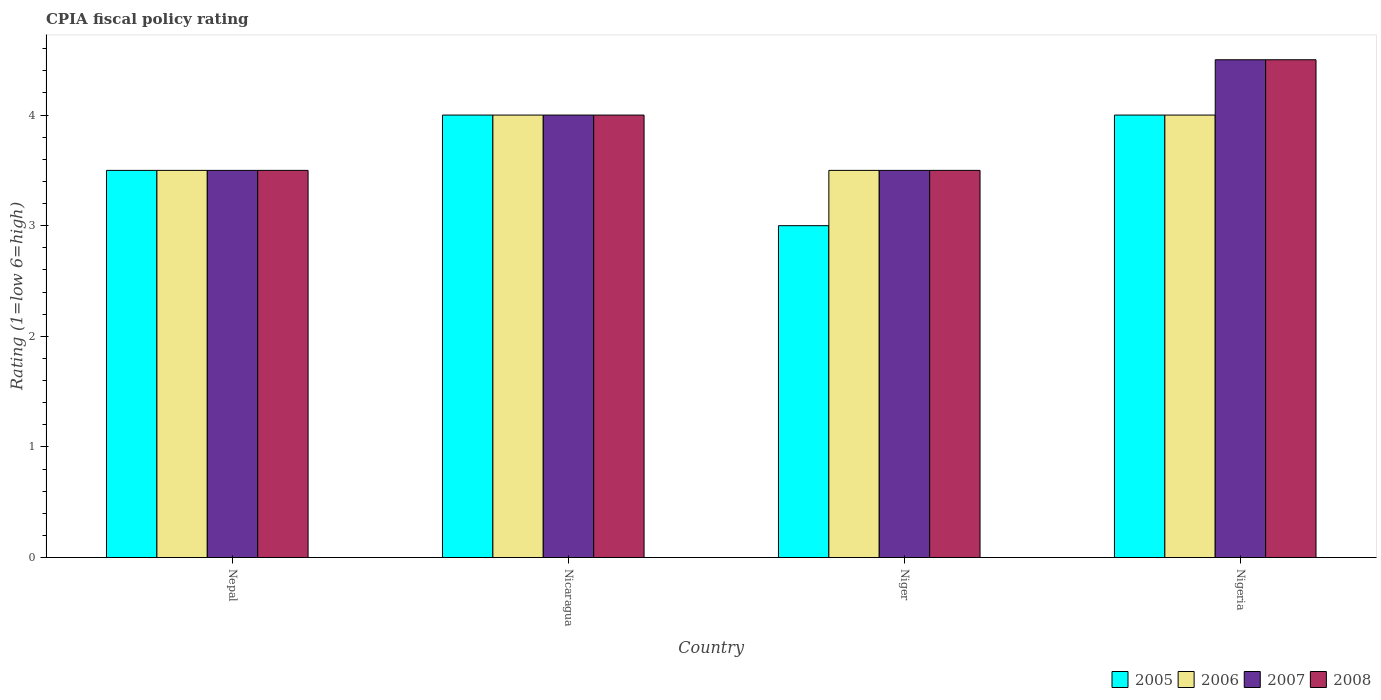How many groups of bars are there?
Provide a short and direct response. 4. How many bars are there on the 3rd tick from the left?
Ensure brevity in your answer.  4. What is the label of the 2nd group of bars from the left?
Offer a very short reply. Nicaragua. In how many cases, is the number of bars for a given country not equal to the number of legend labels?
Keep it short and to the point. 0. What is the CPIA rating in 2008 in Nigeria?
Provide a succinct answer. 4.5. Across all countries, what is the maximum CPIA rating in 2005?
Offer a very short reply. 4. Across all countries, what is the minimum CPIA rating in 2007?
Your answer should be compact. 3.5. In which country was the CPIA rating in 2008 maximum?
Your answer should be compact. Nigeria. In which country was the CPIA rating in 2007 minimum?
Provide a succinct answer. Nepal. What is the total CPIA rating in 2006 in the graph?
Provide a short and direct response. 15. What is the difference between the CPIA rating in 2006 in Nepal and that in Niger?
Give a very brief answer. 0. What is the average CPIA rating in 2005 per country?
Offer a terse response. 3.62. What is the difference between the CPIA rating of/in 2007 and CPIA rating of/in 2006 in Nepal?
Provide a succinct answer. 0. What is the ratio of the CPIA rating in 2006 in Nepal to that in Niger?
Your response must be concise. 1. What is the difference between the highest and the lowest CPIA rating in 2007?
Keep it short and to the point. 1. In how many countries, is the CPIA rating in 2008 greater than the average CPIA rating in 2008 taken over all countries?
Your answer should be compact. 2. Is the sum of the CPIA rating in 2005 in Nicaragua and Niger greater than the maximum CPIA rating in 2008 across all countries?
Your answer should be compact. Yes. Is it the case that in every country, the sum of the CPIA rating in 2007 and CPIA rating in 2005 is greater than the sum of CPIA rating in 2008 and CPIA rating in 2006?
Ensure brevity in your answer.  No. What does the 3rd bar from the left in Nicaragua represents?
Provide a short and direct response. 2007. Is it the case that in every country, the sum of the CPIA rating in 2005 and CPIA rating in 2007 is greater than the CPIA rating in 2008?
Provide a succinct answer. Yes. How many bars are there?
Make the answer very short. 16. What is the difference between two consecutive major ticks on the Y-axis?
Give a very brief answer. 1. Where does the legend appear in the graph?
Offer a terse response. Bottom right. How are the legend labels stacked?
Offer a terse response. Horizontal. What is the title of the graph?
Offer a very short reply. CPIA fiscal policy rating. What is the label or title of the X-axis?
Give a very brief answer. Country. What is the Rating (1=low 6=high) in 2007 in Nepal?
Offer a terse response. 3.5. What is the Rating (1=low 6=high) in 2007 in Nicaragua?
Ensure brevity in your answer.  4. What is the Rating (1=low 6=high) in 2008 in Nicaragua?
Ensure brevity in your answer.  4. What is the Rating (1=low 6=high) of 2007 in Niger?
Provide a short and direct response. 3.5. What is the Rating (1=low 6=high) of 2007 in Nigeria?
Give a very brief answer. 4.5. What is the Rating (1=low 6=high) in 2008 in Nigeria?
Provide a short and direct response. 4.5. Across all countries, what is the maximum Rating (1=low 6=high) of 2005?
Make the answer very short. 4. Across all countries, what is the maximum Rating (1=low 6=high) in 2006?
Your answer should be compact. 4. Across all countries, what is the maximum Rating (1=low 6=high) in 2007?
Offer a terse response. 4.5. Across all countries, what is the maximum Rating (1=low 6=high) of 2008?
Provide a short and direct response. 4.5. Across all countries, what is the minimum Rating (1=low 6=high) of 2008?
Provide a succinct answer. 3.5. What is the total Rating (1=low 6=high) in 2006 in the graph?
Your answer should be compact. 15. What is the total Rating (1=low 6=high) in 2008 in the graph?
Your response must be concise. 15.5. What is the difference between the Rating (1=low 6=high) of 2006 in Nepal and that in Niger?
Give a very brief answer. 0. What is the difference between the Rating (1=low 6=high) of 2007 in Nepal and that in Niger?
Your answer should be compact. 0. What is the difference between the Rating (1=low 6=high) of 2005 in Nepal and that in Nigeria?
Provide a succinct answer. -0.5. What is the difference between the Rating (1=low 6=high) of 2006 in Nepal and that in Nigeria?
Your answer should be compact. -0.5. What is the difference between the Rating (1=low 6=high) of 2005 in Nicaragua and that in Niger?
Your answer should be very brief. 1. What is the difference between the Rating (1=low 6=high) of 2007 in Nicaragua and that in Niger?
Make the answer very short. 0.5. What is the difference between the Rating (1=low 6=high) of 2008 in Nicaragua and that in Niger?
Ensure brevity in your answer.  0.5. What is the difference between the Rating (1=low 6=high) in 2006 in Nicaragua and that in Nigeria?
Ensure brevity in your answer.  0. What is the difference between the Rating (1=low 6=high) of 2007 in Nicaragua and that in Nigeria?
Provide a short and direct response. -0.5. What is the difference between the Rating (1=low 6=high) in 2008 in Nicaragua and that in Nigeria?
Your response must be concise. -0.5. What is the difference between the Rating (1=low 6=high) in 2005 in Niger and that in Nigeria?
Your answer should be very brief. -1. What is the difference between the Rating (1=low 6=high) of 2007 in Niger and that in Nigeria?
Ensure brevity in your answer.  -1. What is the difference between the Rating (1=low 6=high) of 2005 in Nepal and the Rating (1=low 6=high) of 2007 in Nicaragua?
Offer a terse response. -0.5. What is the difference between the Rating (1=low 6=high) of 2006 in Nepal and the Rating (1=low 6=high) of 2008 in Nicaragua?
Your answer should be very brief. -0.5. What is the difference between the Rating (1=low 6=high) in 2005 in Nepal and the Rating (1=low 6=high) in 2006 in Niger?
Give a very brief answer. 0. What is the difference between the Rating (1=low 6=high) in 2005 in Nepal and the Rating (1=low 6=high) in 2007 in Niger?
Your answer should be compact. 0. What is the difference between the Rating (1=low 6=high) of 2005 in Nepal and the Rating (1=low 6=high) of 2008 in Niger?
Keep it short and to the point. 0. What is the difference between the Rating (1=low 6=high) in 2006 in Nepal and the Rating (1=low 6=high) in 2007 in Niger?
Offer a very short reply. 0. What is the difference between the Rating (1=low 6=high) in 2007 in Nepal and the Rating (1=low 6=high) in 2008 in Niger?
Make the answer very short. 0. What is the difference between the Rating (1=low 6=high) in 2005 in Nepal and the Rating (1=low 6=high) in 2006 in Nigeria?
Ensure brevity in your answer.  -0.5. What is the difference between the Rating (1=low 6=high) in 2005 in Nepal and the Rating (1=low 6=high) in 2007 in Nigeria?
Give a very brief answer. -1. What is the difference between the Rating (1=low 6=high) of 2005 in Nepal and the Rating (1=low 6=high) of 2008 in Nigeria?
Make the answer very short. -1. What is the difference between the Rating (1=low 6=high) in 2007 in Nepal and the Rating (1=low 6=high) in 2008 in Nigeria?
Your answer should be compact. -1. What is the difference between the Rating (1=low 6=high) in 2005 in Nicaragua and the Rating (1=low 6=high) in 2007 in Niger?
Provide a succinct answer. 0.5. What is the difference between the Rating (1=low 6=high) in 2005 in Nicaragua and the Rating (1=low 6=high) in 2008 in Niger?
Your answer should be very brief. 0.5. What is the difference between the Rating (1=low 6=high) in 2005 in Nicaragua and the Rating (1=low 6=high) in 2006 in Nigeria?
Your answer should be compact. 0. What is the difference between the Rating (1=low 6=high) in 2005 in Nicaragua and the Rating (1=low 6=high) in 2007 in Nigeria?
Provide a succinct answer. -0.5. What is the difference between the Rating (1=low 6=high) of 2005 in Nicaragua and the Rating (1=low 6=high) of 2008 in Nigeria?
Make the answer very short. -0.5. What is the difference between the Rating (1=low 6=high) of 2006 in Nicaragua and the Rating (1=low 6=high) of 2007 in Nigeria?
Offer a very short reply. -0.5. What is the difference between the Rating (1=low 6=high) in 2006 in Nicaragua and the Rating (1=low 6=high) in 2008 in Nigeria?
Ensure brevity in your answer.  -0.5. What is the difference between the Rating (1=low 6=high) in 2007 in Nicaragua and the Rating (1=low 6=high) in 2008 in Nigeria?
Ensure brevity in your answer.  -0.5. What is the difference between the Rating (1=low 6=high) of 2006 in Niger and the Rating (1=low 6=high) of 2007 in Nigeria?
Your response must be concise. -1. What is the average Rating (1=low 6=high) of 2005 per country?
Ensure brevity in your answer.  3.62. What is the average Rating (1=low 6=high) in 2006 per country?
Give a very brief answer. 3.75. What is the average Rating (1=low 6=high) of 2007 per country?
Give a very brief answer. 3.88. What is the average Rating (1=low 6=high) in 2008 per country?
Give a very brief answer. 3.88. What is the difference between the Rating (1=low 6=high) of 2005 and Rating (1=low 6=high) of 2006 in Nepal?
Ensure brevity in your answer.  0. What is the difference between the Rating (1=low 6=high) of 2005 and Rating (1=low 6=high) of 2008 in Nepal?
Make the answer very short. 0. What is the difference between the Rating (1=low 6=high) of 2006 and Rating (1=low 6=high) of 2008 in Nepal?
Offer a terse response. 0. What is the difference between the Rating (1=low 6=high) in 2005 and Rating (1=low 6=high) in 2006 in Nicaragua?
Your answer should be compact. 0. What is the difference between the Rating (1=low 6=high) of 2005 and Rating (1=low 6=high) of 2006 in Niger?
Give a very brief answer. -0.5. What is the difference between the Rating (1=low 6=high) of 2005 and Rating (1=low 6=high) of 2008 in Niger?
Keep it short and to the point. -0.5. What is the difference between the Rating (1=low 6=high) in 2006 and Rating (1=low 6=high) in 2007 in Niger?
Your answer should be compact. 0. What is the difference between the Rating (1=low 6=high) of 2006 and Rating (1=low 6=high) of 2008 in Niger?
Your response must be concise. 0. What is the difference between the Rating (1=low 6=high) in 2007 and Rating (1=low 6=high) in 2008 in Niger?
Keep it short and to the point. 0. What is the difference between the Rating (1=low 6=high) in 2005 and Rating (1=low 6=high) in 2007 in Nigeria?
Your answer should be compact. -0.5. What is the difference between the Rating (1=low 6=high) of 2005 and Rating (1=low 6=high) of 2008 in Nigeria?
Your answer should be compact. -0.5. What is the difference between the Rating (1=low 6=high) in 2007 and Rating (1=low 6=high) in 2008 in Nigeria?
Keep it short and to the point. 0. What is the ratio of the Rating (1=low 6=high) of 2005 in Nepal to that in Nicaragua?
Your answer should be compact. 0.88. What is the ratio of the Rating (1=low 6=high) of 2006 in Nepal to that in Nicaragua?
Offer a very short reply. 0.88. What is the ratio of the Rating (1=low 6=high) of 2008 in Nepal to that in Nicaragua?
Offer a terse response. 0.88. What is the ratio of the Rating (1=low 6=high) of 2007 in Nepal to that in Nigeria?
Make the answer very short. 0.78. What is the ratio of the Rating (1=low 6=high) in 2005 in Nicaragua to that in Niger?
Offer a very short reply. 1.33. What is the ratio of the Rating (1=low 6=high) in 2008 in Nicaragua to that in Niger?
Give a very brief answer. 1.14. What is the ratio of the Rating (1=low 6=high) in 2005 in Nicaragua to that in Nigeria?
Ensure brevity in your answer.  1. What is the ratio of the Rating (1=low 6=high) of 2005 in Niger to that in Nigeria?
Keep it short and to the point. 0.75. What is the ratio of the Rating (1=low 6=high) of 2006 in Niger to that in Nigeria?
Your answer should be very brief. 0.88. What is the difference between the highest and the second highest Rating (1=low 6=high) in 2006?
Your answer should be very brief. 0. What is the difference between the highest and the second highest Rating (1=low 6=high) in 2008?
Keep it short and to the point. 0.5. What is the difference between the highest and the lowest Rating (1=low 6=high) of 2005?
Offer a very short reply. 1. What is the difference between the highest and the lowest Rating (1=low 6=high) in 2007?
Provide a succinct answer. 1. What is the difference between the highest and the lowest Rating (1=low 6=high) in 2008?
Your response must be concise. 1. 